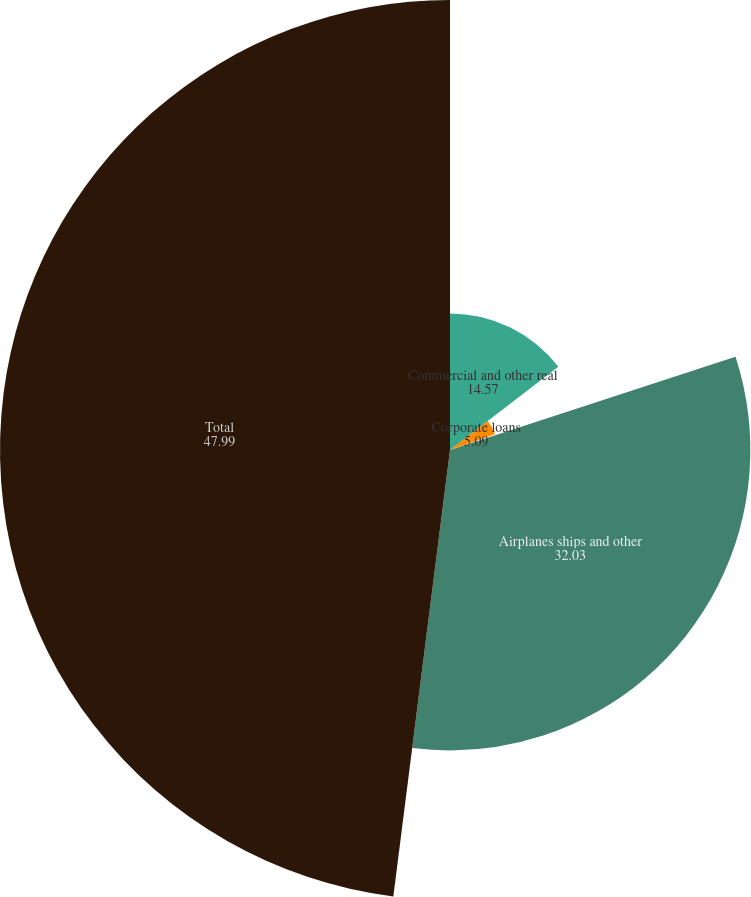Convert chart. <chart><loc_0><loc_0><loc_500><loc_500><pie_chart><fcel>Commercial and other real<fcel>Corporate loans<fcel>Hedge funds and equities<fcel>Airplanes ships and other<fcel>Total<nl><fcel>14.57%<fcel>5.09%<fcel>0.32%<fcel>32.03%<fcel>47.99%<nl></chart> 